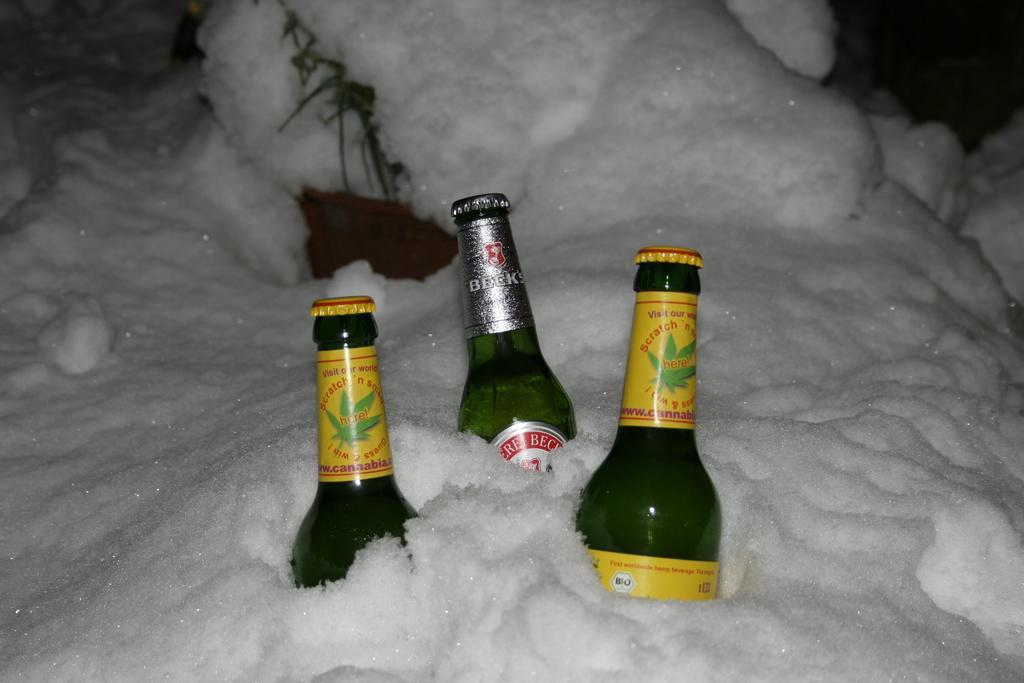In one or two sentences, can you explain what this image depicts? In this see image I can see few bottles are covered in snow. 